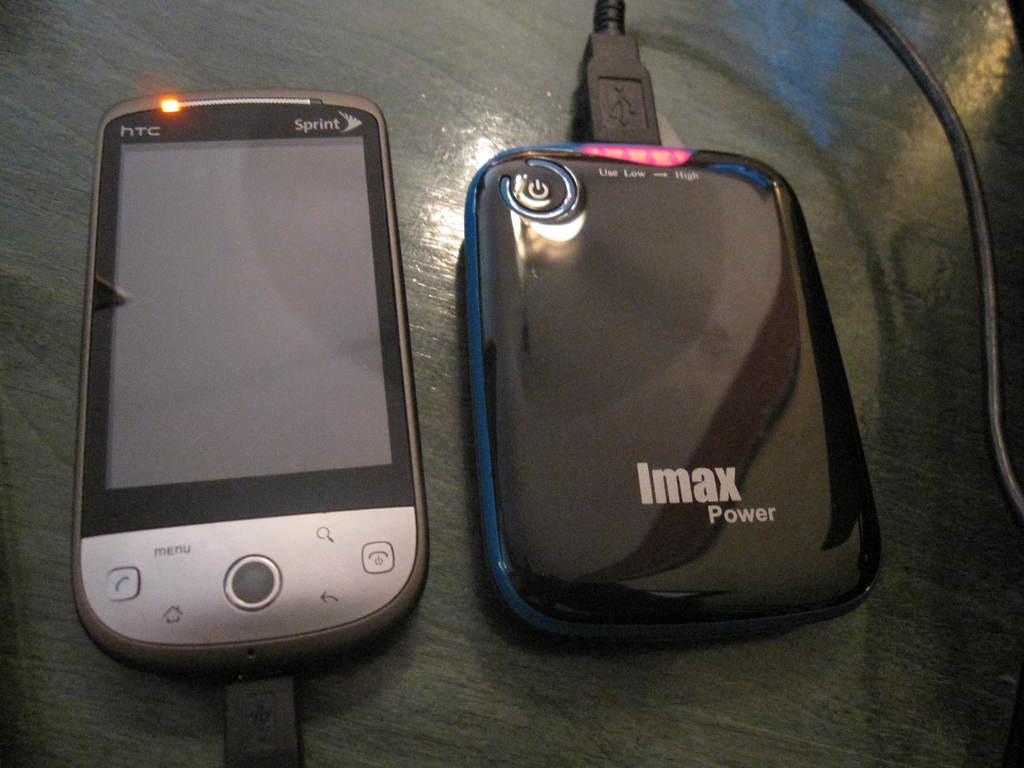<image>
Share a concise interpretation of the image provided. a sprint phone next to an imax power hub 